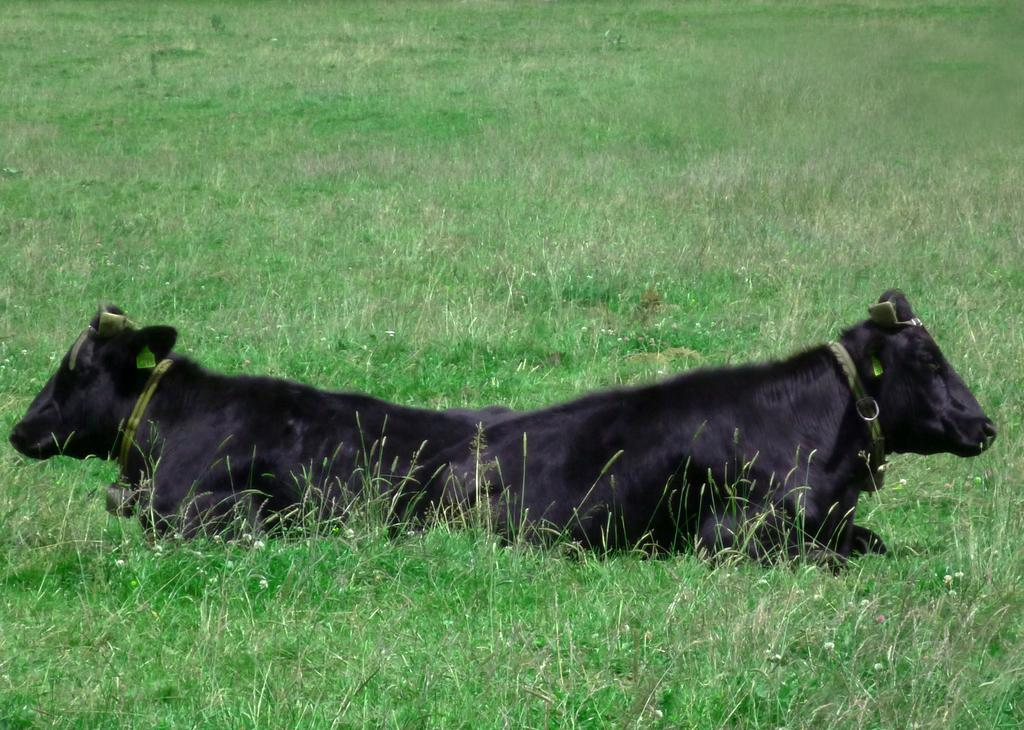How many buffaloes are present in the image? There are two buffaloes in the image. What are the buffaloes doing in the image? The buffaloes are sitting on the grass. What type of picture is hanging on the wall in the image? There is no mention of a picture or a wall in the image; it features two buffaloes sitting on the grass. 